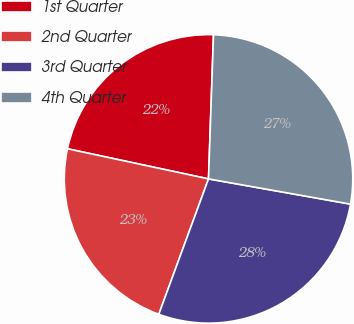Convert chart. <chart><loc_0><loc_0><loc_500><loc_500><pie_chart><fcel>1st Quarter<fcel>2nd Quarter<fcel>3rd Quarter<fcel>4th Quarter<nl><fcel>22.2%<fcel>22.75%<fcel>27.8%<fcel>27.25%<nl></chart> 